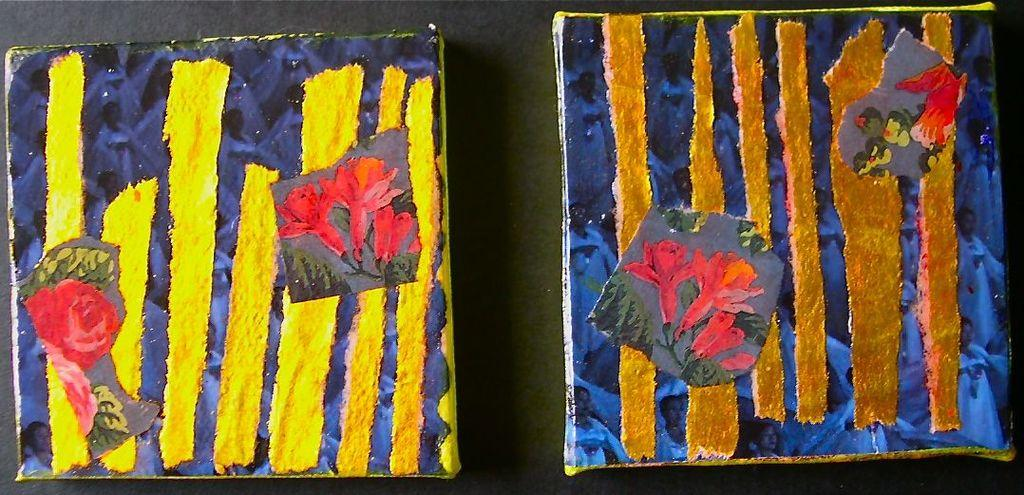How many posters are visible in the image? There are two posters in the image. What can be observed about the appearance of the posters? The posters are painted with colors. What is the background color of the posters are placed on? The posters are placed on a black surface. Can you see a glove on the head of the person in the image? There is no person or glove present in the image; it only features two posters placed on a black surface. 